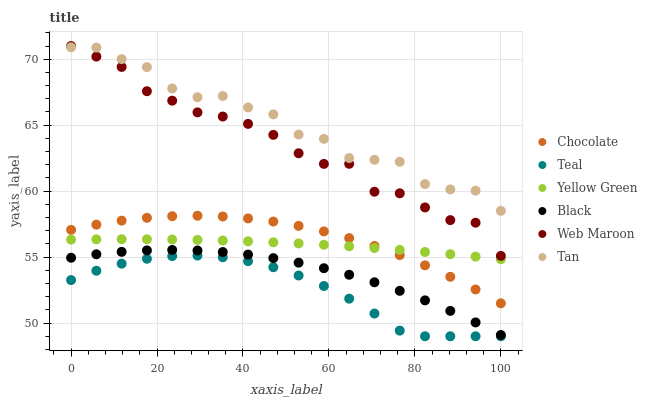Does Teal have the minimum area under the curve?
Answer yes or no. Yes. Does Tan have the maximum area under the curve?
Answer yes or no. Yes. Does Web Maroon have the minimum area under the curve?
Answer yes or no. No. Does Web Maroon have the maximum area under the curve?
Answer yes or no. No. Is Yellow Green the smoothest?
Answer yes or no. Yes. Is Tan the roughest?
Answer yes or no. Yes. Is Web Maroon the smoothest?
Answer yes or no. No. Is Web Maroon the roughest?
Answer yes or no. No. Does Teal have the lowest value?
Answer yes or no. Yes. Does Web Maroon have the lowest value?
Answer yes or no. No. Does Web Maroon have the highest value?
Answer yes or no. Yes. Does Chocolate have the highest value?
Answer yes or no. No. Is Teal less than Tan?
Answer yes or no. Yes. Is Black greater than Teal?
Answer yes or no. Yes. Does Yellow Green intersect Chocolate?
Answer yes or no. Yes. Is Yellow Green less than Chocolate?
Answer yes or no. No. Is Yellow Green greater than Chocolate?
Answer yes or no. No. Does Teal intersect Tan?
Answer yes or no. No. 